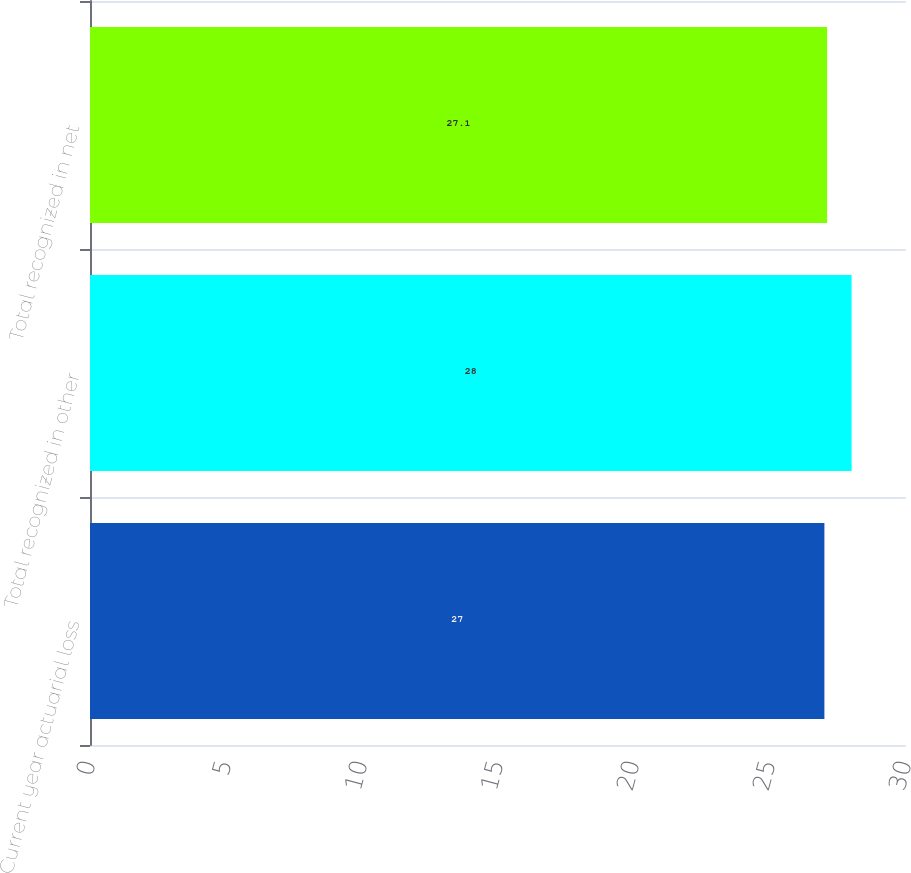Convert chart. <chart><loc_0><loc_0><loc_500><loc_500><bar_chart><fcel>Current year actuarial loss<fcel>Total recognized in other<fcel>Total recognized in net<nl><fcel>27<fcel>28<fcel>27.1<nl></chart> 